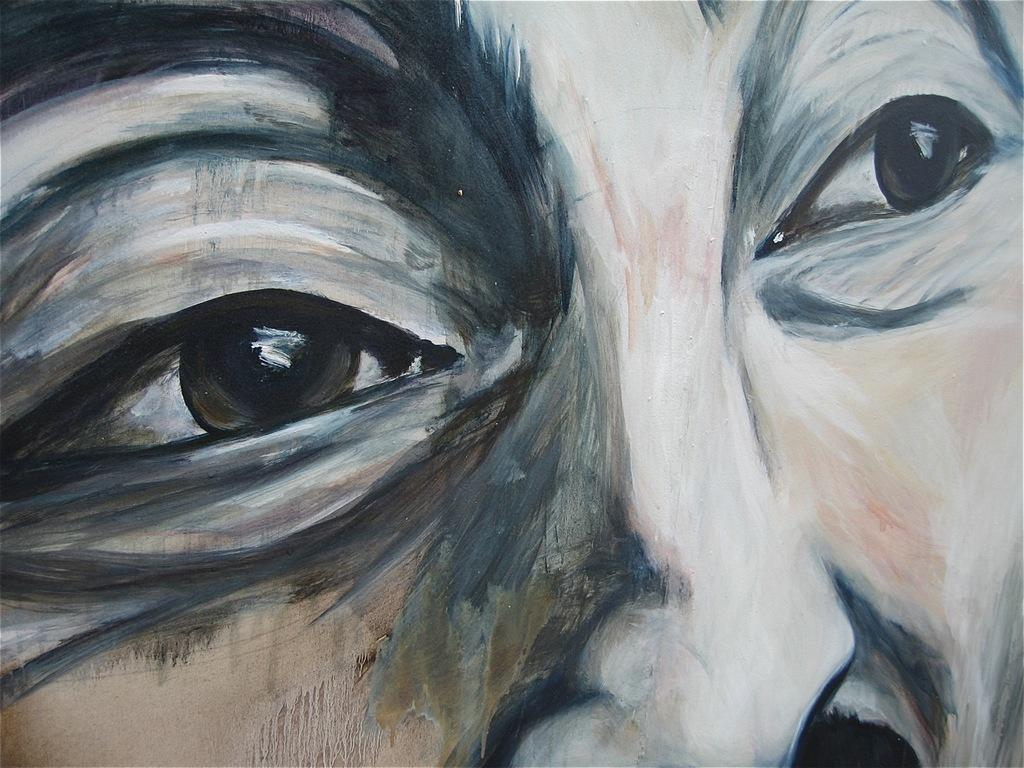What is the main subject of the image? There is a painting in the image. What does the painting depict? The painting depicts a person's face. What facial features can be seen on the person's face in the painting? The person's face has eyes and a nose. What type of furniture is visible in the painting? There is no furniture visible in the painting; it depicts a person's face. What is the chance of the person's face changing expression in the painting? The painting is a static image, so the person's face does not change expression. 